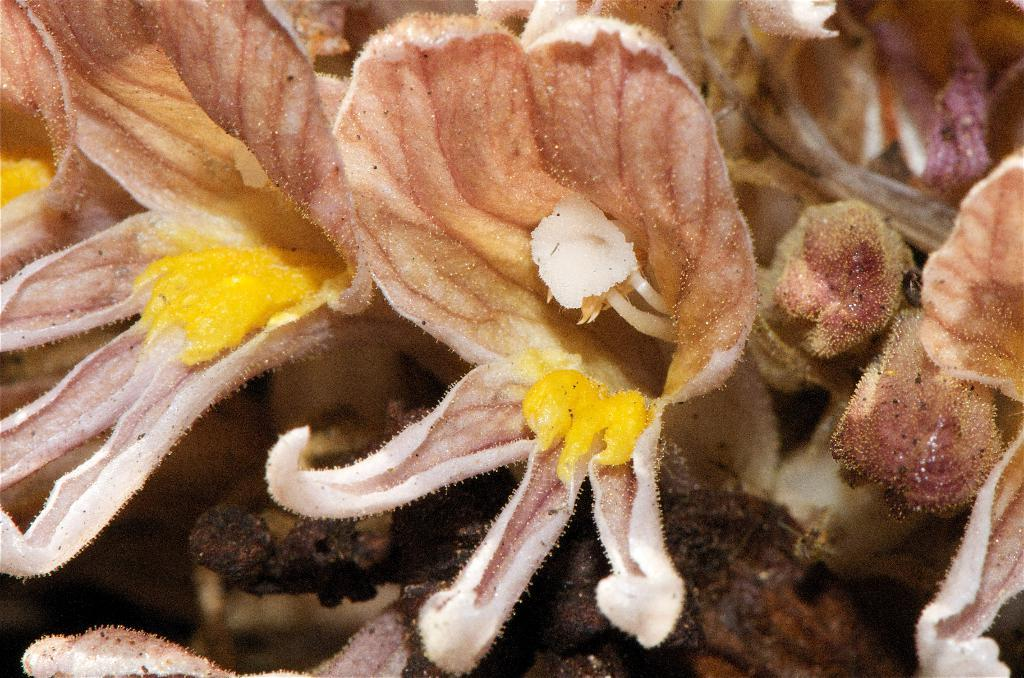What type of plant life is present in the image? There are flowers in the image. What part of the flowers can be seen in the image? Petals are visible in the image. What is present on the flowers that might be involved in pollination? Pollen grains are visible in the image. Can you see a receipt in the image? No, there is no receipt present in the image. 